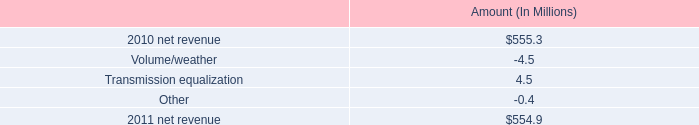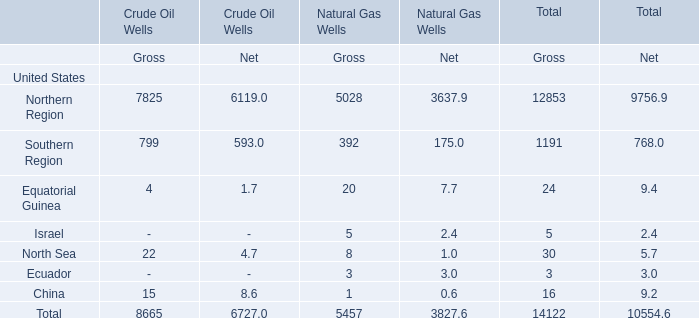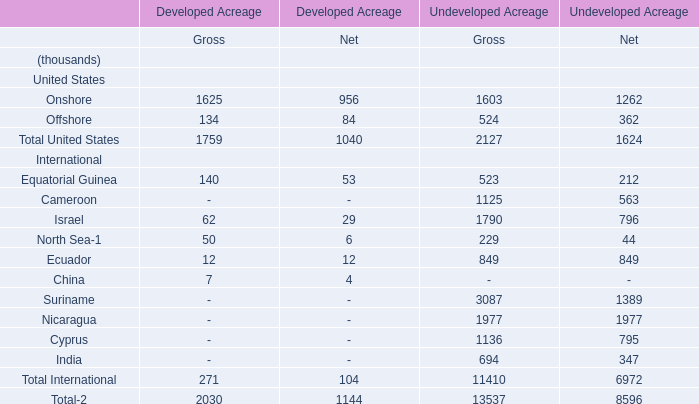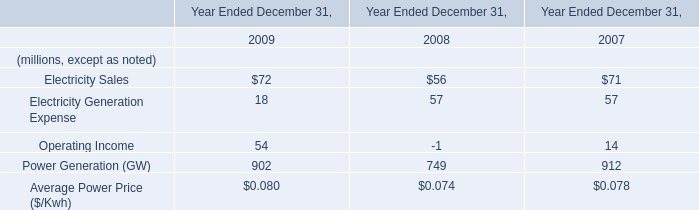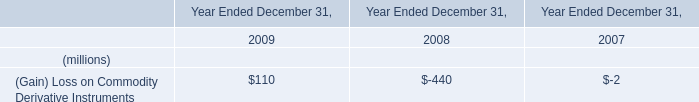What's the sum of Suriname International of Undeveloped Acreage Gross, Northern Region of Crude Oil Wells Net, and Total United States of Undeveloped Acreage Gross ? 
Computations: ((3087.0 + 6119.0) + 2127.0)
Answer: 11333.0. 